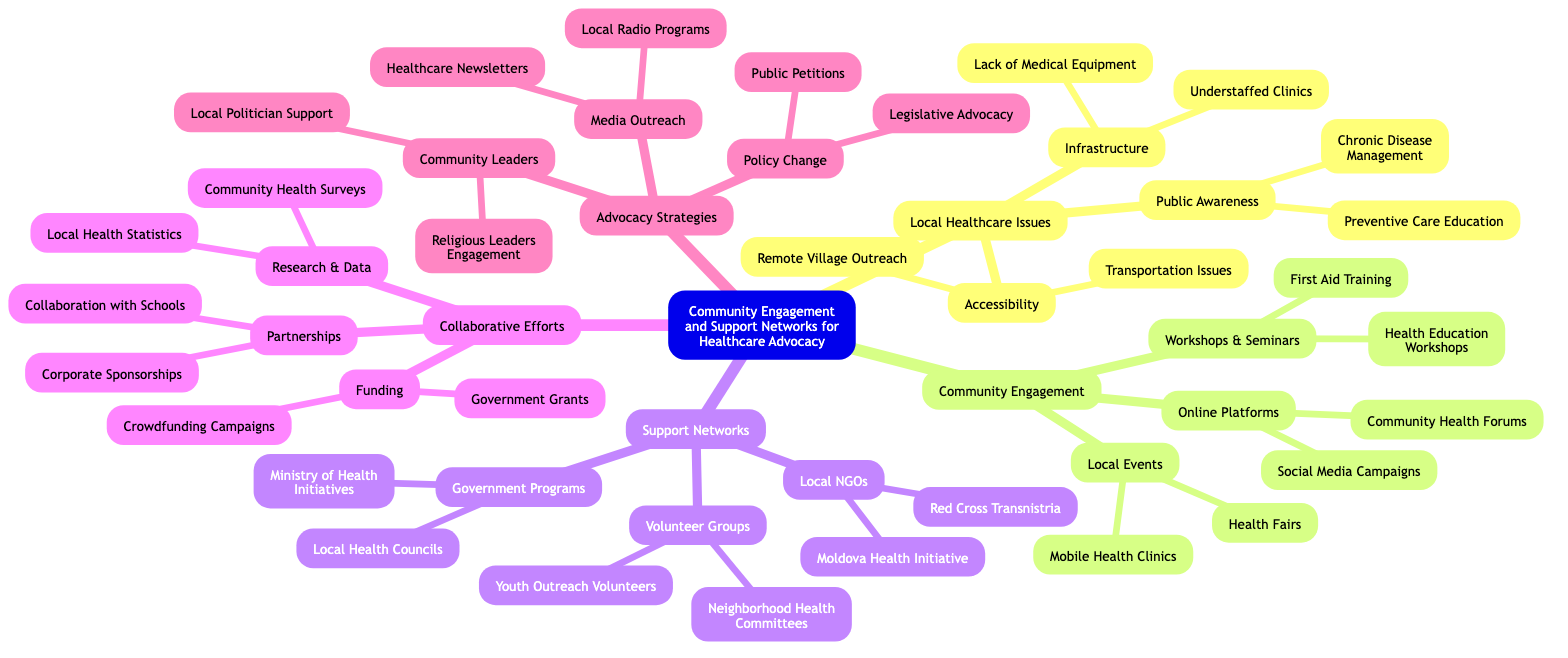What is the central theme of the mind map? The central theme is explicitly stated at the root of the diagram as "Community Engagement and Support Networks for Healthcare Advocacy".
Answer: Community Engagement and Support Networks for Healthcare Advocacy How many subthemes are under Local Healthcare Issues? The subthemes listed are "Infrastructure", "Accessibility", and "Public Awareness", which adds up to three subthemes.
Answer: 3 What are the two subthemes listed under Support Networks? The subthemes under Support Networks are categorized into "Local NGOs", "Government Programs", and "Volunteer Groups". The first two subthemes asked are "Local NGOs" and "Government Programs".
Answer: Local NGOs, Government Programs Which local NGO is mentioned in the Support Networks? One of the local NGOs mentioned is "Red Cross Transnistria". This specific organization is part of a listed category under Support Networks.
Answer: Red Cross Transnistria What advocacy strategy involves public petitions? The advocacy strategy related to public petitions is categorized under "Policy Change". This is indicated in the mind map's established structure.
Answer: Policy Change How many branches are linked to Collaborative Efforts? There are three branches listed under Collaborative Efforts: "Partnerships", "Research & Data", and "Funding", which totals three branches.
Answer: 3 Which type of community event is mentioned that promotes local health? The mind map indicates "Health Fairs" under the subtheme "Local Events", which is a specific type of community event promoting health.
Answer: Health Fairs What is one of the online platforms for community engagement highlighted in the mind map? The mind map lists "Community Health Forums" as one of the online platforms under the subtheme Community Engagement.
Answer: Community Health Forums What type of advocacy strategy could involve local radio programs? The advocacy strategy that could involve local radio programs falls under "Media Outreach". This relationship is clearly defined in the mind map.
Answer: Media Outreach 